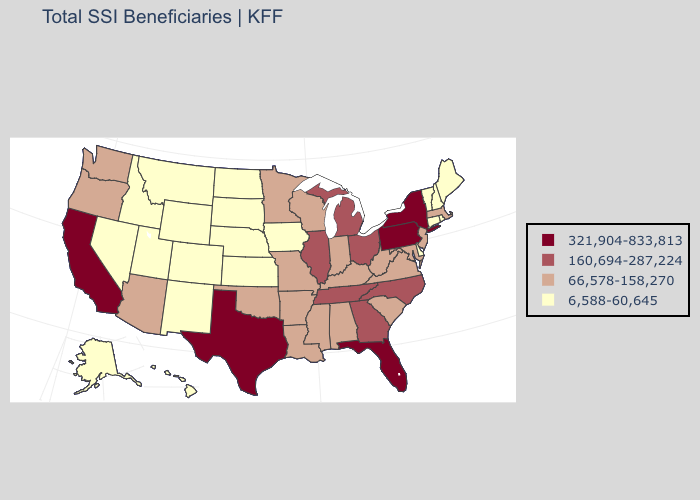Which states have the lowest value in the USA?
Quick response, please. Alaska, Colorado, Connecticut, Delaware, Hawaii, Idaho, Iowa, Kansas, Maine, Montana, Nebraska, Nevada, New Hampshire, New Mexico, North Dakota, Rhode Island, South Dakota, Utah, Vermont, Wyoming. Name the states that have a value in the range 6,588-60,645?
Give a very brief answer. Alaska, Colorado, Connecticut, Delaware, Hawaii, Idaho, Iowa, Kansas, Maine, Montana, Nebraska, Nevada, New Hampshire, New Mexico, North Dakota, Rhode Island, South Dakota, Utah, Vermont, Wyoming. Does Pennsylvania have the highest value in the USA?
Write a very short answer. Yes. Does Tennessee have the highest value in the South?
Give a very brief answer. No. Which states hav the highest value in the West?
Short answer required. California. What is the value of Ohio?
Answer briefly. 160,694-287,224. Among the states that border Wisconsin , which have the lowest value?
Answer briefly. Iowa. What is the lowest value in states that border Oklahoma?
Write a very short answer. 6,588-60,645. What is the highest value in the USA?
Concise answer only. 321,904-833,813. What is the value of New Hampshire?
Short answer required. 6,588-60,645. Name the states that have a value in the range 321,904-833,813?
Concise answer only. California, Florida, New York, Pennsylvania, Texas. Among the states that border Missouri , does Iowa have the lowest value?
Concise answer only. Yes. What is the highest value in the USA?
Answer briefly. 321,904-833,813. Which states hav the highest value in the MidWest?
Answer briefly. Illinois, Michigan, Ohio. 